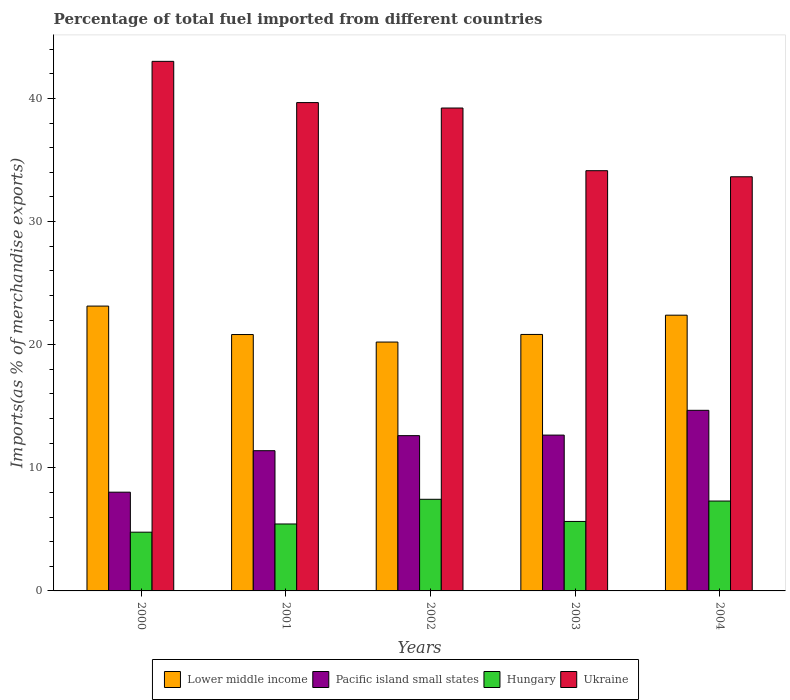How many different coloured bars are there?
Offer a terse response. 4. How many groups of bars are there?
Your answer should be very brief. 5. What is the percentage of imports to different countries in Pacific island small states in 2004?
Provide a succinct answer. 14.67. Across all years, what is the maximum percentage of imports to different countries in Pacific island small states?
Your response must be concise. 14.67. Across all years, what is the minimum percentage of imports to different countries in Pacific island small states?
Give a very brief answer. 8.02. In which year was the percentage of imports to different countries in Lower middle income maximum?
Give a very brief answer. 2000. In which year was the percentage of imports to different countries in Hungary minimum?
Keep it short and to the point. 2000. What is the total percentage of imports to different countries in Pacific island small states in the graph?
Your answer should be compact. 59.34. What is the difference between the percentage of imports to different countries in Ukraine in 2001 and that in 2002?
Make the answer very short. 0.44. What is the difference between the percentage of imports to different countries in Pacific island small states in 2003 and the percentage of imports to different countries in Hungary in 2002?
Provide a succinct answer. 5.21. What is the average percentage of imports to different countries in Lower middle income per year?
Give a very brief answer. 21.48. In the year 2002, what is the difference between the percentage of imports to different countries in Pacific island small states and percentage of imports to different countries in Hungary?
Ensure brevity in your answer.  5.17. In how many years, is the percentage of imports to different countries in Hungary greater than 30 %?
Your answer should be compact. 0. What is the ratio of the percentage of imports to different countries in Lower middle income in 2000 to that in 2002?
Offer a very short reply. 1.14. Is the difference between the percentage of imports to different countries in Pacific island small states in 2001 and 2002 greater than the difference between the percentage of imports to different countries in Hungary in 2001 and 2002?
Provide a short and direct response. Yes. What is the difference between the highest and the second highest percentage of imports to different countries in Ukraine?
Provide a succinct answer. 3.35. What is the difference between the highest and the lowest percentage of imports to different countries in Ukraine?
Offer a very short reply. 9.37. Is it the case that in every year, the sum of the percentage of imports to different countries in Ukraine and percentage of imports to different countries in Lower middle income is greater than the sum of percentage of imports to different countries in Hungary and percentage of imports to different countries in Pacific island small states?
Offer a terse response. Yes. What does the 2nd bar from the left in 2002 represents?
Provide a short and direct response. Pacific island small states. What does the 3rd bar from the right in 2004 represents?
Your answer should be very brief. Pacific island small states. Is it the case that in every year, the sum of the percentage of imports to different countries in Ukraine and percentage of imports to different countries in Hungary is greater than the percentage of imports to different countries in Lower middle income?
Ensure brevity in your answer.  Yes. How many bars are there?
Give a very brief answer. 20. Are all the bars in the graph horizontal?
Ensure brevity in your answer.  No. Does the graph contain grids?
Your answer should be very brief. No. Where does the legend appear in the graph?
Give a very brief answer. Bottom center. What is the title of the graph?
Offer a very short reply. Percentage of total fuel imported from different countries. Does "Oman" appear as one of the legend labels in the graph?
Your answer should be compact. No. What is the label or title of the X-axis?
Provide a short and direct response. Years. What is the label or title of the Y-axis?
Keep it short and to the point. Imports(as % of merchandise exports). What is the Imports(as % of merchandise exports) in Lower middle income in 2000?
Your answer should be very brief. 23.13. What is the Imports(as % of merchandise exports) in Pacific island small states in 2000?
Your response must be concise. 8.02. What is the Imports(as % of merchandise exports) of Hungary in 2000?
Provide a succinct answer. 4.77. What is the Imports(as % of merchandise exports) in Ukraine in 2000?
Your answer should be very brief. 43.01. What is the Imports(as % of merchandise exports) of Lower middle income in 2001?
Keep it short and to the point. 20.82. What is the Imports(as % of merchandise exports) in Pacific island small states in 2001?
Ensure brevity in your answer.  11.39. What is the Imports(as % of merchandise exports) of Hungary in 2001?
Make the answer very short. 5.44. What is the Imports(as % of merchandise exports) of Ukraine in 2001?
Provide a short and direct response. 39.66. What is the Imports(as % of merchandise exports) in Lower middle income in 2002?
Your answer should be very brief. 20.21. What is the Imports(as % of merchandise exports) of Pacific island small states in 2002?
Your response must be concise. 12.61. What is the Imports(as % of merchandise exports) of Hungary in 2002?
Your answer should be very brief. 7.44. What is the Imports(as % of merchandise exports) of Ukraine in 2002?
Provide a succinct answer. 39.22. What is the Imports(as % of merchandise exports) in Lower middle income in 2003?
Your answer should be compact. 20.83. What is the Imports(as % of merchandise exports) of Pacific island small states in 2003?
Offer a terse response. 12.66. What is the Imports(as % of merchandise exports) of Hungary in 2003?
Ensure brevity in your answer.  5.64. What is the Imports(as % of merchandise exports) of Ukraine in 2003?
Your answer should be compact. 34.13. What is the Imports(as % of merchandise exports) in Lower middle income in 2004?
Your response must be concise. 22.4. What is the Imports(as % of merchandise exports) in Pacific island small states in 2004?
Provide a succinct answer. 14.67. What is the Imports(as % of merchandise exports) in Hungary in 2004?
Ensure brevity in your answer.  7.3. What is the Imports(as % of merchandise exports) of Ukraine in 2004?
Give a very brief answer. 33.64. Across all years, what is the maximum Imports(as % of merchandise exports) of Lower middle income?
Provide a succinct answer. 23.13. Across all years, what is the maximum Imports(as % of merchandise exports) in Pacific island small states?
Offer a terse response. 14.67. Across all years, what is the maximum Imports(as % of merchandise exports) of Hungary?
Keep it short and to the point. 7.44. Across all years, what is the maximum Imports(as % of merchandise exports) of Ukraine?
Provide a succinct answer. 43.01. Across all years, what is the minimum Imports(as % of merchandise exports) of Lower middle income?
Ensure brevity in your answer.  20.21. Across all years, what is the minimum Imports(as % of merchandise exports) in Pacific island small states?
Your response must be concise. 8.02. Across all years, what is the minimum Imports(as % of merchandise exports) of Hungary?
Ensure brevity in your answer.  4.77. Across all years, what is the minimum Imports(as % of merchandise exports) of Ukraine?
Provide a short and direct response. 33.64. What is the total Imports(as % of merchandise exports) of Lower middle income in the graph?
Provide a succinct answer. 107.39. What is the total Imports(as % of merchandise exports) in Pacific island small states in the graph?
Make the answer very short. 59.34. What is the total Imports(as % of merchandise exports) in Hungary in the graph?
Keep it short and to the point. 30.59. What is the total Imports(as % of merchandise exports) of Ukraine in the graph?
Your answer should be compact. 189.66. What is the difference between the Imports(as % of merchandise exports) of Lower middle income in 2000 and that in 2001?
Provide a short and direct response. 2.31. What is the difference between the Imports(as % of merchandise exports) in Pacific island small states in 2000 and that in 2001?
Provide a short and direct response. -3.37. What is the difference between the Imports(as % of merchandise exports) of Hungary in 2000 and that in 2001?
Provide a succinct answer. -0.67. What is the difference between the Imports(as % of merchandise exports) in Ukraine in 2000 and that in 2001?
Provide a succinct answer. 3.35. What is the difference between the Imports(as % of merchandise exports) of Lower middle income in 2000 and that in 2002?
Offer a terse response. 2.92. What is the difference between the Imports(as % of merchandise exports) in Pacific island small states in 2000 and that in 2002?
Make the answer very short. -4.59. What is the difference between the Imports(as % of merchandise exports) of Hungary in 2000 and that in 2002?
Give a very brief answer. -2.67. What is the difference between the Imports(as % of merchandise exports) of Ukraine in 2000 and that in 2002?
Keep it short and to the point. 3.79. What is the difference between the Imports(as % of merchandise exports) in Lower middle income in 2000 and that in 2003?
Offer a very short reply. 2.3. What is the difference between the Imports(as % of merchandise exports) in Pacific island small states in 2000 and that in 2003?
Keep it short and to the point. -4.64. What is the difference between the Imports(as % of merchandise exports) in Hungary in 2000 and that in 2003?
Your answer should be compact. -0.87. What is the difference between the Imports(as % of merchandise exports) of Ukraine in 2000 and that in 2003?
Ensure brevity in your answer.  8.88. What is the difference between the Imports(as % of merchandise exports) in Lower middle income in 2000 and that in 2004?
Offer a very short reply. 0.74. What is the difference between the Imports(as % of merchandise exports) in Pacific island small states in 2000 and that in 2004?
Your response must be concise. -6.65. What is the difference between the Imports(as % of merchandise exports) of Hungary in 2000 and that in 2004?
Provide a succinct answer. -2.53. What is the difference between the Imports(as % of merchandise exports) of Ukraine in 2000 and that in 2004?
Your answer should be very brief. 9.37. What is the difference between the Imports(as % of merchandise exports) of Lower middle income in 2001 and that in 2002?
Offer a terse response. 0.61. What is the difference between the Imports(as % of merchandise exports) in Pacific island small states in 2001 and that in 2002?
Keep it short and to the point. -1.22. What is the difference between the Imports(as % of merchandise exports) in Hungary in 2001 and that in 2002?
Offer a terse response. -2.01. What is the difference between the Imports(as % of merchandise exports) of Ukraine in 2001 and that in 2002?
Your answer should be compact. 0.44. What is the difference between the Imports(as % of merchandise exports) in Lower middle income in 2001 and that in 2003?
Offer a very short reply. -0.01. What is the difference between the Imports(as % of merchandise exports) of Pacific island small states in 2001 and that in 2003?
Your response must be concise. -1.27. What is the difference between the Imports(as % of merchandise exports) of Hungary in 2001 and that in 2003?
Give a very brief answer. -0.21. What is the difference between the Imports(as % of merchandise exports) of Ukraine in 2001 and that in 2003?
Your answer should be compact. 5.53. What is the difference between the Imports(as % of merchandise exports) of Lower middle income in 2001 and that in 2004?
Provide a short and direct response. -1.57. What is the difference between the Imports(as % of merchandise exports) of Pacific island small states in 2001 and that in 2004?
Provide a succinct answer. -3.28. What is the difference between the Imports(as % of merchandise exports) in Hungary in 2001 and that in 2004?
Your response must be concise. -1.86. What is the difference between the Imports(as % of merchandise exports) in Ukraine in 2001 and that in 2004?
Offer a very short reply. 6.02. What is the difference between the Imports(as % of merchandise exports) of Lower middle income in 2002 and that in 2003?
Provide a succinct answer. -0.62. What is the difference between the Imports(as % of merchandise exports) of Pacific island small states in 2002 and that in 2003?
Make the answer very short. -0.04. What is the difference between the Imports(as % of merchandise exports) in Hungary in 2002 and that in 2003?
Ensure brevity in your answer.  1.8. What is the difference between the Imports(as % of merchandise exports) of Ukraine in 2002 and that in 2003?
Give a very brief answer. 5.09. What is the difference between the Imports(as % of merchandise exports) of Lower middle income in 2002 and that in 2004?
Offer a very short reply. -2.18. What is the difference between the Imports(as % of merchandise exports) of Pacific island small states in 2002 and that in 2004?
Provide a succinct answer. -2.06. What is the difference between the Imports(as % of merchandise exports) in Hungary in 2002 and that in 2004?
Your answer should be compact. 0.14. What is the difference between the Imports(as % of merchandise exports) in Ukraine in 2002 and that in 2004?
Offer a very short reply. 5.58. What is the difference between the Imports(as % of merchandise exports) of Lower middle income in 2003 and that in 2004?
Offer a very short reply. -1.56. What is the difference between the Imports(as % of merchandise exports) of Pacific island small states in 2003 and that in 2004?
Your response must be concise. -2.01. What is the difference between the Imports(as % of merchandise exports) of Hungary in 2003 and that in 2004?
Give a very brief answer. -1.66. What is the difference between the Imports(as % of merchandise exports) in Ukraine in 2003 and that in 2004?
Provide a succinct answer. 0.49. What is the difference between the Imports(as % of merchandise exports) of Lower middle income in 2000 and the Imports(as % of merchandise exports) of Pacific island small states in 2001?
Provide a succinct answer. 11.74. What is the difference between the Imports(as % of merchandise exports) of Lower middle income in 2000 and the Imports(as % of merchandise exports) of Hungary in 2001?
Offer a terse response. 17.7. What is the difference between the Imports(as % of merchandise exports) of Lower middle income in 2000 and the Imports(as % of merchandise exports) of Ukraine in 2001?
Your answer should be compact. -16.53. What is the difference between the Imports(as % of merchandise exports) in Pacific island small states in 2000 and the Imports(as % of merchandise exports) in Hungary in 2001?
Your answer should be very brief. 2.58. What is the difference between the Imports(as % of merchandise exports) in Pacific island small states in 2000 and the Imports(as % of merchandise exports) in Ukraine in 2001?
Offer a very short reply. -31.64. What is the difference between the Imports(as % of merchandise exports) of Hungary in 2000 and the Imports(as % of merchandise exports) of Ukraine in 2001?
Ensure brevity in your answer.  -34.89. What is the difference between the Imports(as % of merchandise exports) in Lower middle income in 2000 and the Imports(as % of merchandise exports) in Pacific island small states in 2002?
Give a very brief answer. 10.52. What is the difference between the Imports(as % of merchandise exports) of Lower middle income in 2000 and the Imports(as % of merchandise exports) of Hungary in 2002?
Provide a short and direct response. 15.69. What is the difference between the Imports(as % of merchandise exports) in Lower middle income in 2000 and the Imports(as % of merchandise exports) in Ukraine in 2002?
Ensure brevity in your answer.  -16.09. What is the difference between the Imports(as % of merchandise exports) of Pacific island small states in 2000 and the Imports(as % of merchandise exports) of Hungary in 2002?
Provide a short and direct response. 0.58. What is the difference between the Imports(as % of merchandise exports) in Pacific island small states in 2000 and the Imports(as % of merchandise exports) in Ukraine in 2002?
Your response must be concise. -31.2. What is the difference between the Imports(as % of merchandise exports) in Hungary in 2000 and the Imports(as % of merchandise exports) in Ukraine in 2002?
Ensure brevity in your answer.  -34.45. What is the difference between the Imports(as % of merchandise exports) in Lower middle income in 2000 and the Imports(as % of merchandise exports) in Pacific island small states in 2003?
Make the answer very short. 10.48. What is the difference between the Imports(as % of merchandise exports) of Lower middle income in 2000 and the Imports(as % of merchandise exports) of Hungary in 2003?
Offer a very short reply. 17.49. What is the difference between the Imports(as % of merchandise exports) of Lower middle income in 2000 and the Imports(as % of merchandise exports) of Ukraine in 2003?
Provide a short and direct response. -11. What is the difference between the Imports(as % of merchandise exports) in Pacific island small states in 2000 and the Imports(as % of merchandise exports) in Hungary in 2003?
Offer a very short reply. 2.38. What is the difference between the Imports(as % of merchandise exports) of Pacific island small states in 2000 and the Imports(as % of merchandise exports) of Ukraine in 2003?
Offer a terse response. -26.11. What is the difference between the Imports(as % of merchandise exports) of Hungary in 2000 and the Imports(as % of merchandise exports) of Ukraine in 2003?
Keep it short and to the point. -29.36. What is the difference between the Imports(as % of merchandise exports) in Lower middle income in 2000 and the Imports(as % of merchandise exports) in Pacific island small states in 2004?
Provide a succinct answer. 8.47. What is the difference between the Imports(as % of merchandise exports) in Lower middle income in 2000 and the Imports(as % of merchandise exports) in Hungary in 2004?
Your response must be concise. 15.83. What is the difference between the Imports(as % of merchandise exports) in Lower middle income in 2000 and the Imports(as % of merchandise exports) in Ukraine in 2004?
Provide a succinct answer. -10.5. What is the difference between the Imports(as % of merchandise exports) of Pacific island small states in 2000 and the Imports(as % of merchandise exports) of Hungary in 2004?
Your answer should be compact. 0.72. What is the difference between the Imports(as % of merchandise exports) of Pacific island small states in 2000 and the Imports(as % of merchandise exports) of Ukraine in 2004?
Offer a terse response. -25.62. What is the difference between the Imports(as % of merchandise exports) in Hungary in 2000 and the Imports(as % of merchandise exports) in Ukraine in 2004?
Ensure brevity in your answer.  -28.87. What is the difference between the Imports(as % of merchandise exports) of Lower middle income in 2001 and the Imports(as % of merchandise exports) of Pacific island small states in 2002?
Make the answer very short. 8.21. What is the difference between the Imports(as % of merchandise exports) in Lower middle income in 2001 and the Imports(as % of merchandise exports) in Hungary in 2002?
Your answer should be very brief. 13.38. What is the difference between the Imports(as % of merchandise exports) in Lower middle income in 2001 and the Imports(as % of merchandise exports) in Ukraine in 2002?
Offer a very short reply. -18.4. What is the difference between the Imports(as % of merchandise exports) in Pacific island small states in 2001 and the Imports(as % of merchandise exports) in Hungary in 2002?
Offer a very short reply. 3.95. What is the difference between the Imports(as % of merchandise exports) of Pacific island small states in 2001 and the Imports(as % of merchandise exports) of Ukraine in 2002?
Your answer should be very brief. -27.83. What is the difference between the Imports(as % of merchandise exports) of Hungary in 2001 and the Imports(as % of merchandise exports) of Ukraine in 2002?
Provide a succinct answer. -33.78. What is the difference between the Imports(as % of merchandise exports) in Lower middle income in 2001 and the Imports(as % of merchandise exports) in Pacific island small states in 2003?
Give a very brief answer. 8.17. What is the difference between the Imports(as % of merchandise exports) of Lower middle income in 2001 and the Imports(as % of merchandise exports) of Hungary in 2003?
Give a very brief answer. 15.18. What is the difference between the Imports(as % of merchandise exports) in Lower middle income in 2001 and the Imports(as % of merchandise exports) in Ukraine in 2003?
Make the answer very short. -13.31. What is the difference between the Imports(as % of merchandise exports) in Pacific island small states in 2001 and the Imports(as % of merchandise exports) in Hungary in 2003?
Ensure brevity in your answer.  5.75. What is the difference between the Imports(as % of merchandise exports) of Pacific island small states in 2001 and the Imports(as % of merchandise exports) of Ukraine in 2003?
Offer a very short reply. -22.74. What is the difference between the Imports(as % of merchandise exports) of Hungary in 2001 and the Imports(as % of merchandise exports) of Ukraine in 2003?
Offer a very short reply. -28.69. What is the difference between the Imports(as % of merchandise exports) of Lower middle income in 2001 and the Imports(as % of merchandise exports) of Pacific island small states in 2004?
Your answer should be very brief. 6.15. What is the difference between the Imports(as % of merchandise exports) of Lower middle income in 2001 and the Imports(as % of merchandise exports) of Hungary in 2004?
Ensure brevity in your answer.  13.52. What is the difference between the Imports(as % of merchandise exports) of Lower middle income in 2001 and the Imports(as % of merchandise exports) of Ukraine in 2004?
Offer a very short reply. -12.81. What is the difference between the Imports(as % of merchandise exports) in Pacific island small states in 2001 and the Imports(as % of merchandise exports) in Hungary in 2004?
Your answer should be very brief. 4.09. What is the difference between the Imports(as % of merchandise exports) of Pacific island small states in 2001 and the Imports(as % of merchandise exports) of Ukraine in 2004?
Make the answer very short. -22.25. What is the difference between the Imports(as % of merchandise exports) in Hungary in 2001 and the Imports(as % of merchandise exports) in Ukraine in 2004?
Provide a succinct answer. -28.2. What is the difference between the Imports(as % of merchandise exports) in Lower middle income in 2002 and the Imports(as % of merchandise exports) in Pacific island small states in 2003?
Your answer should be very brief. 7.56. What is the difference between the Imports(as % of merchandise exports) in Lower middle income in 2002 and the Imports(as % of merchandise exports) in Hungary in 2003?
Keep it short and to the point. 14.57. What is the difference between the Imports(as % of merchandise exports) in Lower middle income in 2002 and the Imports(as % of merchandise exports) in Ukraine in 2003?
Provide a succinct answer. -13.92. What is the difference between the Imports(as % of merchandise exports) in Pacific island small states in 2002 and the Imports(as % of merchandise exports) in Hungary in 2003?
Your answer should be very brief. 6.97. What is the difference between the Imports(as % of merchandise exports) of Pacific island small states in 2002 and the Imports(as % of merchandise exports) of Ukraine in 2003?
Ensure brevity in your answer.  -21.52. What is the difference between the Imports(as % of merchandise exports) of Hungary in 2002 and the Imports(as % of merchandise exports) of Ukraine in 2003?
Your response must be concise. -26.69. What is the difference between the Imports(as % of merchandise exports) of Lower middle income in 2002 and the Imports(as % of merchandise exports) of Pacific island small states in 2004?
Your answer should be compact. 5.54. What is the difference between the Imports(as % of merchandise exports) of Lower middle income in 2002 and the Imports(as % of merchandise exports) of Hungary in 2004?
Your response must be concise. 12.91. What is the difference between the Imports(as % of merchandise exports) in Lower middle income in 2002 and the Imports(as % of merchandise exports) in Ukraine in 2004?
Offer a terse response. -13.42. What is the difference between the Imports(as % of merchandise exports) of Pacific island small states in 2002 and the Imports(as % of merchandise exports) of Hungary in 2004?
Your answer should be compact. 5.31. What is the difference between the Imports(as % of merchandise exports) in Pacific island small states in 2002 and the Imports(as % of merchandise exports) in Ukraine in 2004?
Make the answer very short. -21.03. What is the difference between the Imports(as % of merchandise exports) of Hungary in 2002 and the Imports(as % of merchandise exports) of Ukraine in 2004?
Your answer should be very brief. -26.19. What is the difference between the Imports(as % of merchandise exports) of Lower middle income in 2003 and the Imports(as % of merchandise exports) of Pacific island small states in 2004?
Give a very brief answer. 6.16. What is the difference between the Imports(as % of merchandise exports) of Lower middle income in 2003 and the Imports(as % of merchandise exports) of Hungary in 2004?
Ensure brevity in your answer.  13.53. What is the difference between the Imports(as % of merchandise exports) in Lower middle income in 2003 and the Imports(as % of merchandise exports) in Ukraine in 2004?
Provide a succinct answer. -12.81. What is the difference between the Imports(as % of merchandise exports) in Pacific island small states in 2003 and the Imports(as % of merchandise exports) in Hungary in 2004?
Make the answer very short. 5.36. What is the difference between the Imports(as % of merchandise exports) in Pacific island small states in 2003 and the Imports(as % of merchandise exports) in Ukraine in 2004?
Your response must be concise. -20.98. What is the difference between the Imports(as % of merchandise exports) of Hungary in 2003 and the Imports(as % of merchandise exports) of Ukraine in 2004?
Offer a terse response. -27.99. What is the average Imports(as % of merchandise exports) in Lower middle income per year?
Offer a terse response. 21.48. What is the average Imports(as % of merchandise exports) in Pacific island small states per year?
Offer a very short reply. 11.87. What is the average Imports(as % of merchandise exports) in Hungary per year?
Provide a succinct answer. 6.12. What is the average Imports(as % of merchandise exports) in Ukraine per year?
Offer a terse response. 37.93. In the year 2000, what is the difference between the Imports(as % of merchandise exports) in Lower middle income and Imports(as % of merchandise exports) in Pacific island small states?
Make the answer very short. 15.11. In the year 2000, what is the difference between the Imports(as % of merchandise exports) of Lower middle income and Imports(as % of merchandise exports) of Hungary?
Your response must be concise. 18.36. In the year 2000, what is the difference between the Imports(as % of merchandise exports) of Lower middle income and Imports(as % of merchandise exports) of Ukraine?
Make the answer very short. -19.88. In the year 2000, what is the difference between the Imports(as % of merchandise exports) of Pacific island small states and Imports(as % of merchandise exports) of Hungary?
Offer a terse response. 3.25. In the year 2000, what is the difference between the Imports(as % of merchandise exports) in Pacific island small states and Imports(as % of merchandise exports) in Ukraine?
Your response must be concise. -34.99. In the year 2000, what is the difference between the Imports(as % of merchandise exports) of Hungary and Imports(as % of merchandise exports) of Ukraine?
Your response must be concise. -38.24. In the year 2001, what is the difference between the Imports(as % of merchandise exports) in Lower middle income and Imports(as % of merchandise exports) in Pacific island small states?
Offer a very short reply. 9.43. In the year 2001, what is the difference between the Imports(as % of merchandise exports) in Lower middle income and Imports(as % of merchandise exports) in Hungary?
Provide a succinct answer. 15.39. In the year 2001, what is the difference between the Imports(as % of merchandise exports) in Lower middle income and Imports(as % of merchandise exports) in Ukraine?
Give a very brief answer. -18.84. In the year 2001, what is the difference between the Imports(as % of merchandise exports) in Pacific island small states and Imports(as % of merchandise exports) in Hungary?
Offer a very short reply. 5.95. In the year 2001, what is the difference between the Imports(as % of merchandise exports) in Pacific island small states and Imports(as % of merchandise exports) in Ukraine?
Keep it short and to the point. -28.27. In the year 2001, what is the difference between the Imports(as % of merchandise exports) of Hungary and Imports(as % of merchandise exports) of Ukraine?
Your response must be concise. -34.22. In the year 2002, what is the difference between the Imports(as % of merchandise exports) of Lower middle income and Imports(as % of merchandise exports) of Pacific island small states?
Give a very brief answer. 7.6. In the year 2002, what is the difference between the Imports(as % of merchandise exports) of Lower middle income and Imports(as % of merchandise exports) of Hungary?
Provide a succinct answer. 12.77. In the year 2002, what is the difference between the Imports(as % of merchandise exports) of Lower middle income and Imports(as % of merchandise exports) of Ukraine?
Offer a very short reply. -19.01. In the year 2002, what is the difference between the Imports(as % of merchandise exports) in Pacific island small states and Imports(as % of merchandise exports) in Hungary?
Provide a succinct answer. 5.17. In the year 2002, what is the difference between the Imports(as % of merchandise exports) of Pacific island small states and Imports(as % of merchandise exports) of Ukraine?
Your answer should be compact. -26.61. In the year 2002, what is the difference between the Imports(as % of merchandise exports) of Hungary and Imports(as % of merchandise exports) of Ukraine?
Make the answer very short. -31.78. In the year 2003, what is the difference between the Imports(as % of merchandise exports) in Lower middle income and Imports(as % of merchandise exports) in Pacific island small states?
Give a very brief answer. 8.17. In the year 2003, what is the difference between the Imports(as % of merchandise exports) in Lower middle income and Imports(as % of merchandise exports) in Hungary?
Provide a succinct answer. 15.19. In the year 2003, what is the difference between the Imports(as % of merchandise exports) of Lower middle income and Imports(as % of merchandise exports) of Ukraine?
Your answer should be very brief. -13.3. In the year 2003, what is the difference between the Imports(as % of merchandise exports) in Pacific island small states and Imports(as % of merchandise exports) in Hungary?
Your response must be concise. 7.01. In the year 2003, what is the difference between the Imports(as % of merchandise exports) in Pacific island small states and Imports(as % of merchandise exports) in Ukraine?
Provide a short and direct response. -21.47. In the year 2003, what is the difference between the Imports(as % of merchandise exports) of Hungary and Imports(as % of merchandise exports) of Ukraine?
Your response must be concise. -28.49. In the year 2004, what is the difference between the Imports(as % of merchandise exports) of Lower middle income and Imports(as % of merchandise exports) of Pacific island small states?
Give a very brief answer. 7.73. In the year 2004, what is the difference between the Imports(as % of merchandise exports) of Lower middle income and Imports(as % of merchandise exports) of Hungary?
Your response must be concise. 15.1. In the year 2004, what is the difference between the Imports(as % of merchandise exports) in Lower middle income and Imports(as % of merchandise exports) in Ukraine?
Ensure brevity in your answer.  -11.24. In the year 2004, what is the difference between the Imports(as % of merchandise exports) of Pacific island small states and Imports(as % of merchandise exports) of Hungary?
Offer a terse response. 7.37. In the year 2004, what is the difference between the Imports(as % of merchandise exports) in Pacific island small states and Imports(as % of merchandise exports) in Ukraine?
Give a very brief answer. -18.97. In the year 2004, what is the difference between the Imports(as % of merchandise exports) of Hungary and Imports(as % of merchandise exports) of Ukraine?
Provide a succinct answer. -26.34. What is the ratio of the Imports(as % of merchandise exports) in Lower middle income in 2000 to that in 2001?
Offer a very short reply. 1.11. What is the ratio of the Imports(as % of merchandise exports) of Pacific island small states in 2000 to that in 2001?
Give a very brief answer. 0.7. What is the ratio of the Imports(as % of merchandise exports) of Hungary in 2000 to that in 2001?
Your answer should be compact. 0.88. What is the ratio of the Imports(as % of merchandise exports) in Ukraine in 2000 to that in 2001?
Provide a short and direct response. 1.08. What is the ratio of the Imports(as % of merchandise exports) of Lower middle income in 2000 to that in 2002?
Make the answer very short. 1.14. What is the ratio of the Imports(as % of merchandise exports) of Pacific island small states in 2000 to that in 2002?
Make the answer very short. 0.64. What is the ratio of the Imports(as % of merchandise exports) in Hungary in 2000 to that in 2002?
Make the answer very short. 0.64. What is the ratio of the Imports(as % of merchandise exports) in Ukraine in 2000 to that in 2002?
Make the answer very short. 1.1. What is the ratio of the Imports(as % of merchandise exports) in Lower middle income in 2000 to that in 2003?
Make the answer very short. 1.11. What is the ratio of the Imports(as % of merchandise exports) in Pacific island small states in 2000 to that in 2003?
Ensure brevity in your answer.  0.63. What is the ratio of the Imports(as % of merchandise exports) of Hungary in 2000 to that in 2003?
Ensure brevity in your answer.  0.85. What is the ratio of the Imports(as % of merchandise exports) in Ukraine in 2000 to that in 2003?
Give a very brief answer. 1.26. What is the ratio of the Imports(as % of merchandise exports) of Lower middle income in 2000 to that in 2004?
Your response must be concise. 1.03. What is the ratio of the Imports(as % of merchandise exports) of Pacific island small states in 2000 to that in 2004?
Make the answer very short. 0.55. What is the ratio of the Imports(as % of merchandise exports) in Hungary in 2000 to that in 2004?
Provide a short and direct response. 0.65. What is the ratio of the Imports(as % of merchandise exports) of Ukraine in 2000 to that in 2004?
Make the answer very short. 1.28. What is the ratio of the Imports(as % of merchandise exports) of Lower middle income in 2001 to that in 2002?
Make the answer very short. 1.03. What is the ratio of the Imports(as % of merchandise exports) in Pacific island small states in 2001 to that in 2002?
Provide a succinct answer. 0.9. What is the ratio of the Imports(as % of merchandise exports) of Hungary in 2001 to that in 2002?
Provide a short and direct response. 0.73. What is the ratio of the Imports(as % of merchandise exports) of Ukraine in 2001 to that in 2002?
Give a very brief answer. 1.01. What is the ratio of the Imports(as % of merchandise exports) in Pacific island small states in 2001 to that in 2003?
Your answer should be compact. 0.9. What is the ratio of the Imports(as % of merchandise exports) of Hungary in 2001 to that in 2003?
Offer a very short reply. 0.96. What is the ratio of the Imports(as % of merchandise exports) of Ukraine in 2001 to that in 2003?
Your answer should be compact. 1.16. What is the ratio of the Imports(as % of merchandise exports) in Lower middle income in 2001 to that in 2004?
Keep it short and to the point. 0.93. What is the ratio of the Imports(as % of merchandise exports) of Pacific island small states in 2001 to that in 2004?
Provide a short and direct response. 0.78. What is the ratio of the Imports(as % of merchandise exports) in Hungary in 2001 to that in 2004?
Your response must be concise. 0.74. What is the ratio of the Imports(as % of merchandise exports) in Ukraine in 2001 to that in 2004?
Offer a terse response. 1.18. What is the ratio of the Imports(as % of merchandise exports) in Lower middle income in 2002 to that in 2003?
Make the answer very short. 0.97. What is the ratio of the Imports(as % of merchandise exports) of Pacific island small states in 2002 to that in 2003?
Offer a terse response. 1. What is the ratio of the Imports(as % of merchandise exports) of Hungary in 2002 to that in 2003?
Give a very brief answer. 1.32. What is the ratio of the Imports(as % of merchandise exports) of Ukraine in 2002 to that in 2003?
Your answer should be very brief. 1.15. What is the ratio of the Imports(as % of merchandise exports) in Lower middle income in 2002 to that in 2004?
Offer a very short reply. 0.9. What is the ratio of the Imports(as % of merchandise exports) in Pacific island small states in 2002 to that in 2004?
Keep it short and to the point. 0.86. What is the ratio of the Imports(as % of merchandise exports) of Hungary in 2002 to that in 2004?
Provide a succinct answer. 1.02. What is the ratio of the Imports(as % of merchandise exports) in Ukraine in 2002 to that in 2004?
Keep it short and to the point. 1.17. What is the ratio of the Imports(as % of merchandise exports) of Lower middle income in 2003 to that in 2004?
Ensure brevity in your answer.  0.93. What is the ratio of the Imports(as % of merchandise exports) of Pacific island small states in 2003 to that in 2004?
Ensure brevity in your answer.  0.86. What is the ratio of the Imports(as % of merchandise exports) in Hungary in 2003 to that in 2004?
Provide a succinct answer. 0.77. What is the ratio of the Imports(as % of merchandise exports) of Ukraine in 2003 to that in 2004?
Provide a succinct answer. 1.01. What is the difference between the highest and the second highest Imports(as % of merchandise exports) of Lower middle income?
Make the answer very short. 0.74. What is the difference between the highest and the second highest Imports(as % of merchandise exports) in Pacific island small states?
Provide a succinct answer. 2.01. What is the difference between the highest and the second highest Imports(as % of merchandise exports) in Hungary?
Your response must be concise. 0.14. What is the difference between the highest and the second highest Imports(as % of merchandise exports) of Ukraine?
Keep it short and to the point. 3.35. What is the difference between the highest and the lowest Imports(as % of merchandise exports) in Lower middle income?
Provide a short and direct response. 2.92. What is the difference between the highest and the lowest Imports(as % of merchandise exports) of Pacific island small states?
Provide a succinct answer. 6.65. What is the difference between the highest and the lowest Imports(as % of merchandise exports) in Hungary?
Provide a succinct answer. 2.67. What is the difference between the highest and the lowest Imports(as % of merchandise exports) of Ukraine?
Provide a succinct answer. 9.37. 